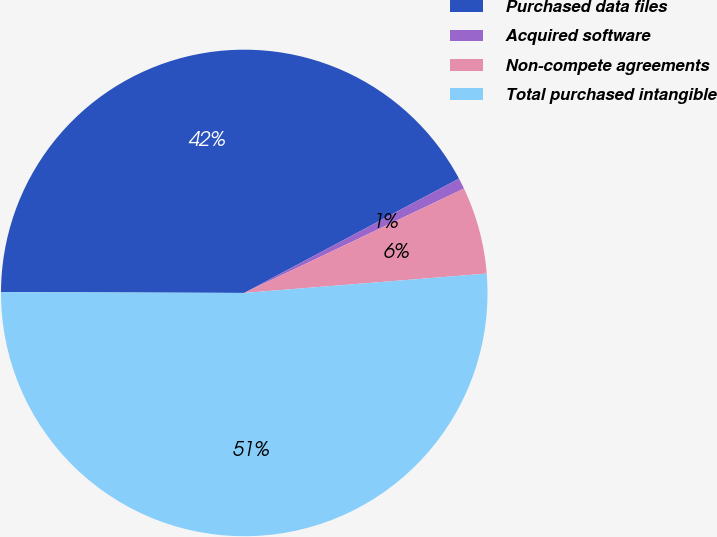Convert chart. <chart><loc_0><loc_0><loc_500><loc_500><pie_chart><fcel>Purchased data files<fcel>Acquired software<fcel>Non-compete agreements<fcel>Total purchased intangible<nl><fcel>42.16%<fcel>0.73%<fcel>5.79%<fcel>51.33%<nl></chart> 